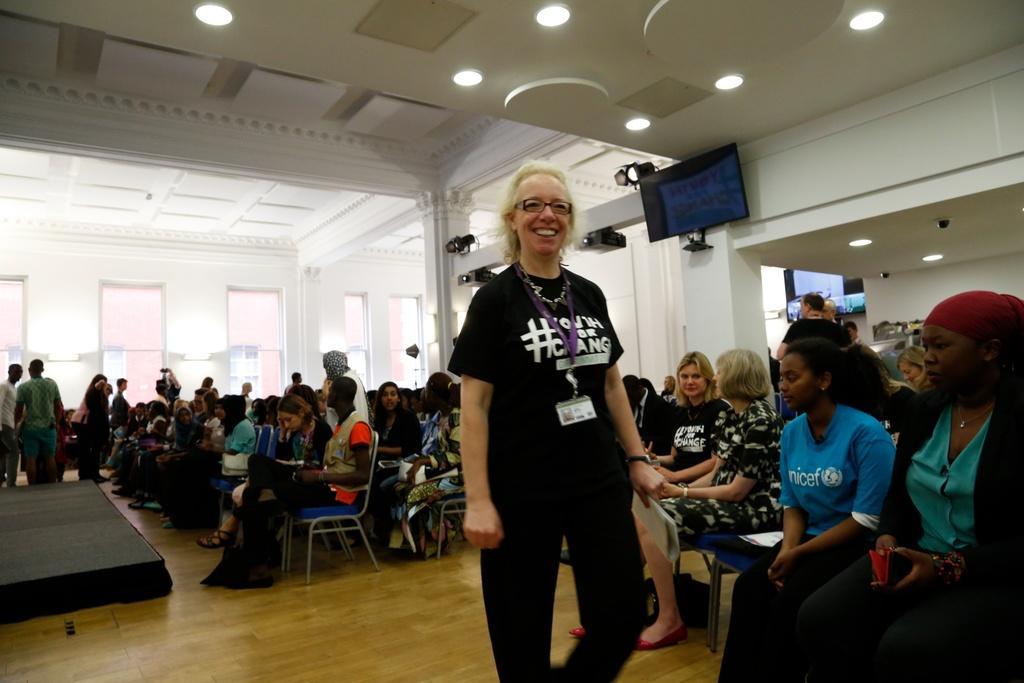Describe this image in one or two sentences. In this image we can see a group of persons sitting on chairs. In the foreground we can see a person standing and the person is holding the papers. Behind the persons we can see a wall and glasses. At the top we can see the roof and lights. There is a television, lights and projectors at the top. On the left side, we can see few persons and a black object looks like a stage. 